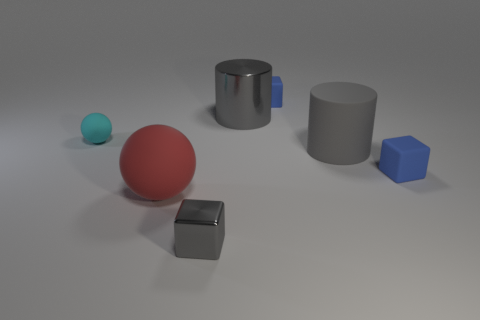Subtract all gray cylinders. How many blue cubes are left? 2 Subtract all tiny metallic cubes. How many cubes are left? 2 Add 3 small gray metal objects. How many objects exist? 10 Subtract all balls. How many objects are left? 5 Subtract 1 balls. How many balls are left? 1 Add 7 small gray metal cubes. How many small gray metal cubes exist? 8 Subtract 0 yellow cubes. How many objects are left? 7 Subtract all blue cubes. Subtract all green cylinders. How many cubes are left? 1 Subtract all small spheres. Subtract all metal things. How many objects are left? 4 Add 4 tiny cyan rubber things. How many tiny cyan rubber things are left? 5 